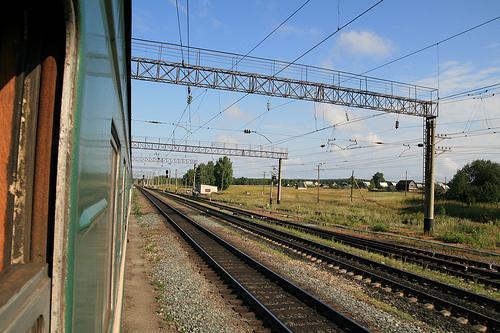How many kangaroos are in this image?
Give a very brief answer. 0. 